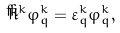Convert formula to latex. <formula><loc_0><loc_0><loc_500><loc_500>\check { h } ^ { k } \varphi _ { q } ^ { k } = \varepsilon _ { q } ^ { k } \varphi _ { q } ^ { k } ,</formula> 